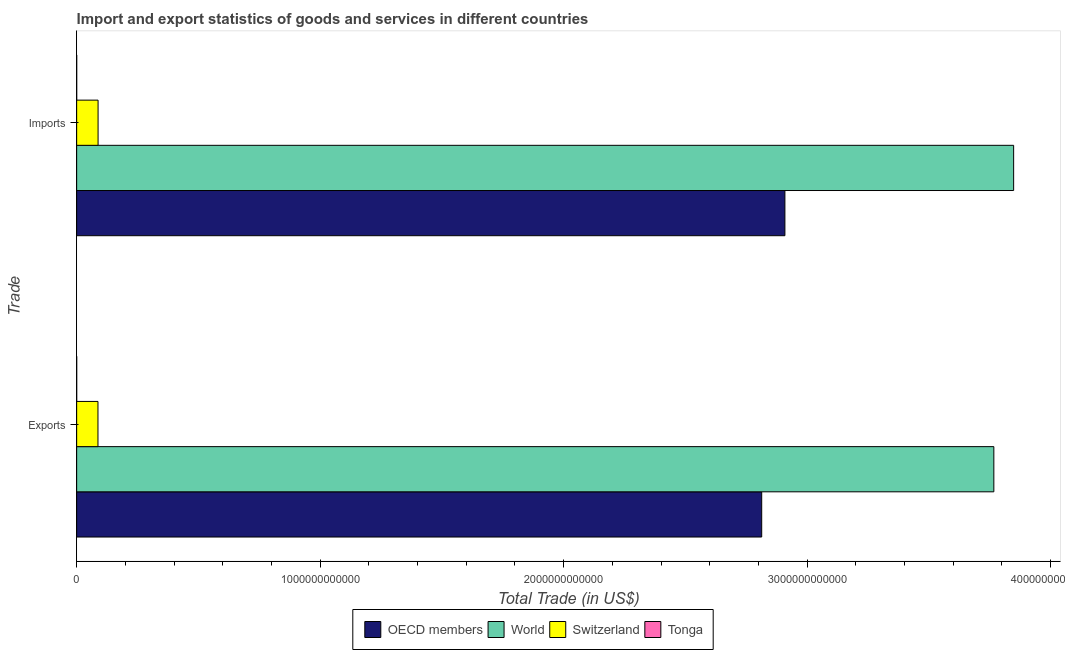How many groups of bars are there?
Your response must be concise. 2. Are the number of bars per tick equal to the number of legend labels?
Offer a very short reply. Yes. Are the number of bars on each tick of the Y-axis equal?
Make the answer very short. Yes. How many bars are there on the 2nd tick from the top?
Offer a terse response. 4. How many bars are there on the 1st tick from the bottom?
Offer a terse response. 4. What is the label of the 1st group of bars from the top?
Keep it short and to the point. Imports. What is the imports of goods and services in Switzerland?
Keep it short and to the point. 8.79e+1. Across all countries, what is the maximum imports of goods and services?
Provide a succinct answer. 3.85e+12. Across all countries, what is the minimum imports of goods and services?
Make the answer very short. 6.68e+07. In which country was the export of goods and services maximum?
Provide a short and direct response. World. In which country was the export of goods and services minimum?
Offer a very short reply. Tonga. What is the total imports of goods and services in the graph?
Offer a very short reply. 6.84e+12. What is the difference between the imports of goods and services in OECD members and that in Tonga?
Provide a short and direct response. 2.91e+12. What is the difference between the export of goods and services in World and the imports of goods and services in Switzerland?
Ensure brevity in your answer.  3.68e+12. What is the average export of goods and services per country?
Provide a succinct answer. 1.67e+12. What is the difference between the export of goods and services and imports of goods and services in World?
Provide a short and direct response. -8.13e+1. In how many countries, is the imports of goods and services greater than 3600000000000 US$?
Provide a succinct answer. 1. What is the ratio of the imports of goods and services in Tonga to that in OECD members?
Your answer should be compact. 2.296221255861088e-5. Is the imports of goods and services in Switzerland less than that in OECD members?
Make the answer very short. Yes. What does the 2nd bar from the top in Exports represents?
Your answer should be compact. Switzerland. What does the 4th bar from the bottom in Exports represents?
Your response must be concise. Tonga. How many bars are there?
Keep it short and to the point. 8. What is the difference between two consecutive major ticks on the X-axis?
Provide a succinct answer. 1.00e+12. Does the graph contain grids?
Keep it short and to the point. No. What is the title of the graph?
Your response must be concise. Import and export statistics of goods and services in different countries. Does "Barbados" appear as one of the legend labels in the graph?
Provide a short and direct response. No. What is the label or title of the X-axis?
Provide a succinct answer. Total Trade (in US$). What is the label or title of the Y-axis?
Provide a succinct answer. Trade. What is the Total Trade (in US$) in OECD members in Exports?
Provide a succinct answer. 2.81e+12. What is the Total Trade (in US$) of World in Exports?
Your answer should be very brief. 3.77e+12. What is the Total Trade (in US$) of Switzerland in Exports?
Give a very brief answer. 8.75e+1. What is the Total Trade (in US$) of Tonga in Exports?
Offer a terse response. 2.67e+07. What is the Total Trade (in US$) of OECD members in Imports?
Keep it short and to the point. 2.91e+12. What is the Total Trade (in US$) in World in Imports?
Make the answer very short. 3.85e+12. What is the Total Trade (in US$) in Switzerland in Imports?
Keep it short and to the point. 8.79e+1. What is the Total Trade (in US$) of Tonga in Imports?
Keep it short and to the point. 6.68e+07. Across all Trade, what is the maximum Total Trade (in US$) of OECD members?
Provide a succinct answer. 2.91e+12. Across all Trade, what is the maximum Total Trade (in US$) in World?
Ensure brevity in your answer.  3.85e+12. Across all Trade, what is the maximum Total Trade (in US$) of Switzerland?
Your answer should be compact. 8.79e+1. Across all Trade, what is the maximum Total Trade (in US$) in Tonga?
Offer a terse response. 6.68e+07. Across all Trade, what is the minimum Total Trade (in US$) of OECD members?
Ensure brevity in your answer.  2.81e+12. Across all Trade, what is the minimum Total Trade (in US$) in World?
Provide a succinct answer. 3.77e+12. Across all Trade, what is the minimum Total Trade (in US$) in Switzerland?
Your answer should be compact. 8.75e+1. Across all Trade, what is the minimum Total Trade (in US$) of Tonga?
Keep it short and to the point. 2.67e+07. What is the total Total Trade (in US$) in OECD members in the graph?
Provide a succinct answer. 5.72e+12. What is the total Total Trade (in US$) in World in the graph?
Your answer should be compact. 7.61e+12. What is the total Total Trade (in US$) of Switzerland in the graph?
Offer a very short reply. 1.75e+11. What is the total Total Trade (in US$) of Tonga in the graph?
Keep it short and to the point. 9.35e+07. What is the difference between the Total Trade (in US$) in OECD members in Exports and that in Imports?
Provide a succinct answer. -9.53e+1. What is the difference between the Total Trade (in US$) of World in Exports and that in Imports?
Your response must be concise. -8.13e+1. What is the difference between the Total Trade (in US$) of Switzerland in Exports and that in Imports?
Provide a succinct answer. -4.20e+08. What is the difference between the Total Trade (in US$) of Tonga in Exports and that in Imports?
Offer a terse response. -4.01e+07. What is the difference between the Total Trade (in US$) of OECD members in Exports and the Total Trade (in US$) of World in Imports?
Provide a succinct answer. -1.03e+12. What is the difference between the Total Trade (in US$) in OECD members in Exports and the Total Trade (in US$) in Switzerland in Imports?
Ensure brevity in your answer.  2.73e+12. What is the difference between the Total Trade (in US$) in OECD members in Exports and the Total Trade (in US$) in Tonga in Imports?
Make the answer very short. 2.81e+12. What is the difference between the Total Trade (in US$) in World in Exports and the Total Trade (in US$) in Switzerland in Imports?
Your answer should be very brief. 3.68e+12. What is the difference between the Total Trade (in US$) in World in Exports and the Total Trade (in US$) in Tonga in Imports?
Provide a succinct answer. 3.77e+12. What is the difference between the Total Trade (in US$) in Switzerland in Exports and the Total Trade (in US$) in Tonga in Imports?
Offer a terse response. 8.74e+1. What is the average Total Trade (in US$) in OECD members per Trade?
Make the answer very short. 2.86e+12. What is the average Total Trade (in US$) of World per Trade?
Provide a short and direct response. 3.81e+12. What is the average Total Trade (in US$) of Switzerland per Trade?
Give a very brief answer. 8.77e+1. What is the average Total Trade (in US$) in Tonga per Trade?
Make the answer very short. 4.67e+07. What is the difference between the Total Trade (in US$) of OECD members and Total Trade (in US$) of World in Exports?
Provide a short and direct response. -9.53e+11. What is the difference between the Total Trade (in US$) in OECD members and Total Trade (in US$) in Switzerland in Exports?
Give a very brief answer. 2.73e+12. What is the difference between the Total Trade (in US$) of OECD members and Total Trade (in US$) of Tonga in Exports?
Your answer should be very brief. 2.81e+12. What is the difference between the Total Trade (in US$) in World and Total Trade (in US$) in Switzerland in Exports?
Your answer should be very brief. 3.68e+12. What is the difference between the Total Trade (in US$) in World and Total Trade (in US$) in Tonga in Exports?
Your answer should be compact. 3.77e+12. What is the difference between the Total Trade (in US$) in Switzerland and Total Trade (in US$) in Tonga in Exports?
Offer a terse response. 8.75e+1. What is the difference between the Total Trade (in US$) of OECD members and Total Trade (in US$) of World in Imports?
Make the answer very short. -9.39e+11. What is the difference between the Total Trade (in US$) in OECD members and Total Trade (in US$) in Switzerland in Imports?
Your answer should be very brief. 2.82e+12. What is the difference between the Total Trade (in US$) of OECD members and Total Trade (in US$) of Tonga in Imports?
Ensure brevity in your answer.  2.91e+12. What is the difference between the Total Trade (in US$) in World and Total Trade (in US$) in Switzerland in Imports?
Your answer should be very brief. 3.76e+12. What is the difference between the Total Trade (in US$) in World and Total Trade (in US$) in Tonga in Imports?
Your answer should be compact. 3.85e+12. What is the difference between the Total Trade (in US$) in Switzerland and Total Trade (in US$) in Tonga in Imports?
Provide a short and direct response. 8.79e+1. What is the ratio of the Total Trade (in US$) in OECD members in Exports to that in Imports?
Keep it short and to the point. 0.97. What is the ratio of the Total Trade (in US$) in World in Exports to that in Imports?
Your answer should be very brief. 0.98. What is the ratio of the Total Trade (in US$) in Switzerland in Exports to that in Imports?
Make the answer very short. 1. What is the ratio of the Total Trade (in US$) of Tonga in Exports to that in Imports?
Offer a very short reply. 0.4. What is the difference between the highest and the second highest Total Trade (in US$) of OECD members?
Provide a succinct answer. 9.53e+1. What is the difference between the highest and the second highest Total Trade (in US$) of World?
Ensure brevity in your answer.  8.13e+1. What is the difference between the highest and the second highest Total Trade (in US$) of Switzerland?
Offer a very short reply. 4.20e+08. What is the difference between the highest and the second highest Total Trade (in US$) in Tonga?
Make the answer very short. 4.01e+07. What is the difference between the highest and the lowest Total Trade (in US$) in OECD members?
Make the answer very short. 9.53e+1. What is the difference between the highest and the lowest Total Trade (in US$) of World?
Your answer should be very brief. 8.13e+1. What is the difference between the highest and the lowest Total Trade (in US$) of Switzerland?
Your answer should be compact. 4.20e+08. What is the difference between the highest and the lowest Total Trade (in US$) in Tonga?
Offer a very short reply. 4.01e+07. 